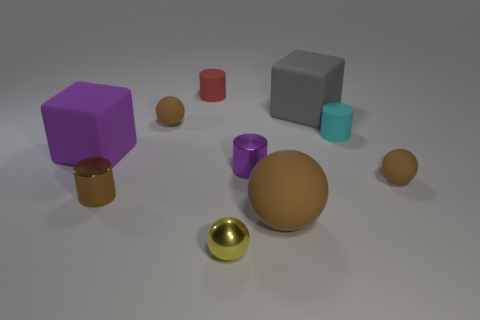How many shiny cylinders are the same size as the gray thing?
Provide a succinct answer. 0. There is a tiny brown thing that is both on the left side of the small red object and behind the brown cylinder; what is it made of?
Your answer should be compact. Rubber. There is a small red matte thing; how many brown things are on the left side of it?
Your response must be concise. 2. There is a tiny cyan matte object; is its shape the same as the tiny brown object that is behind the purple cube?
Give a very brief answer. No. Are there any large green matte things that have the same shape as the small purple shiny thing?
Make the answer very short. No. What shape is the brown rubber object right of the small matte cylinder that is in front of the large gray object?
Keep it short and to the point. Sphere. What shape is the small brown rubber thing on the right side of the red rubber thing?
Offer a very short reply. Sphere. There is a big block to the right of the purple rubber thing; is it the same color as the sphere that is behind the big purple matte block?
Offer a very short reply. No. What number of objects are both to the left of the small cyan cylinder and to the right of the purple matte cube?
Provide a short and direct response. 7. There is a red object that is made of the same material as the small cyan cylinder; what is its size?
Provide a succinct answer. Small. 